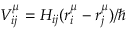<formula> <loc_0><loc_0><loc_500><loc_500>V _ { i j } ^ { \mu } = H _ { i j } ( r _ { i } ^ { \mu } - r _ { j } ^ { \mu } ) / \hbar</formula> 